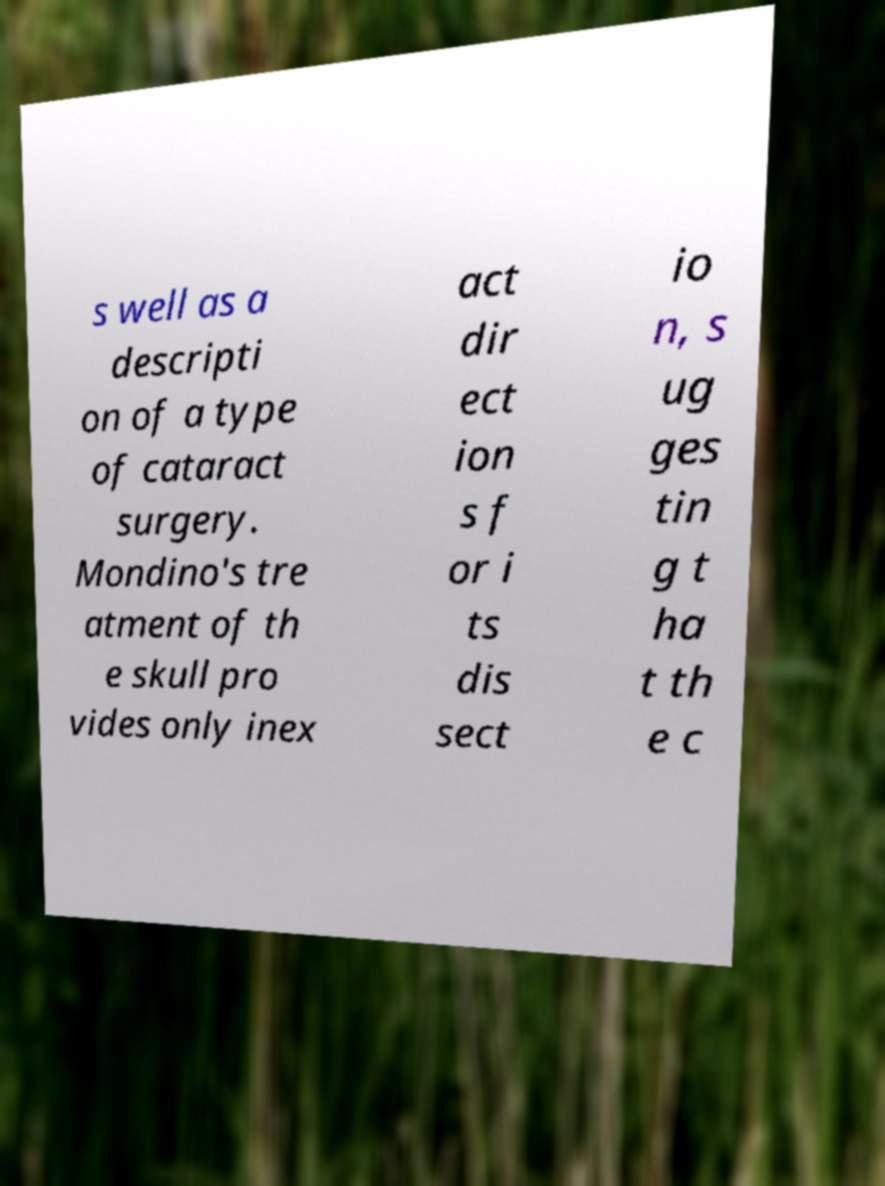For documentation purposes, I need the text within this image transcribed. Could you provide that? s well as a descripti on of a type of cataract surgery. Mondino's tre atment of th e skull pro vides only inex act dir ect ion s f or i ts dis sect io n, s ug ges tin g t ha t th e c 